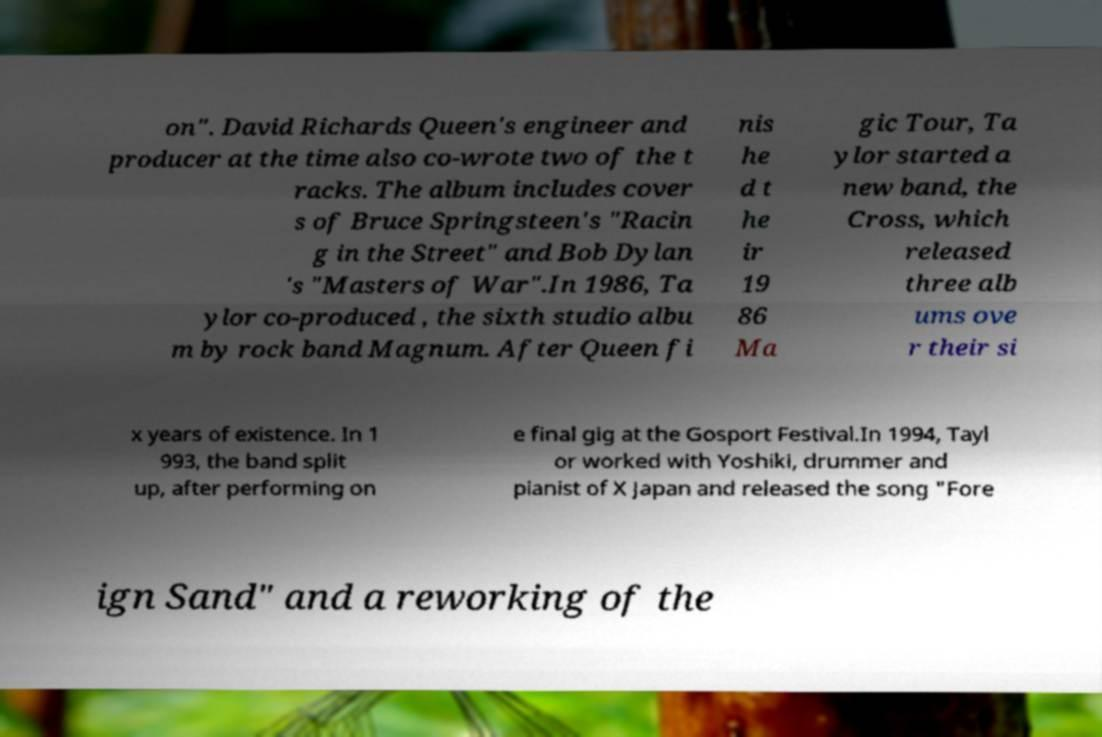What messages or text are displayed in this image? I need them in a readable, typed format. on". David Richards Queen's engineer and producer at the time also co-wrote two of the t racks. The album includes cover s of Bruce Springsteen's "Racin g in the Street" and Bob Dylan 's "Masters of War".In 1986, Ta ylor co-produced , the sixth studio albu m by rock band Magnum. After Queen fi nis he d t he ir 19 86 Ma gic Tour, Ta ylor started a new band, the Cross, which released three alb ums ove r their si x years of existence. In 1 993, the band split up, after performing on e final gig at the Gosport Festival.In 1994, Tayl or worked with Yoshiki, drummer and pianist of X Japan and released the song "Fore ign Sand" and a reworking of the 